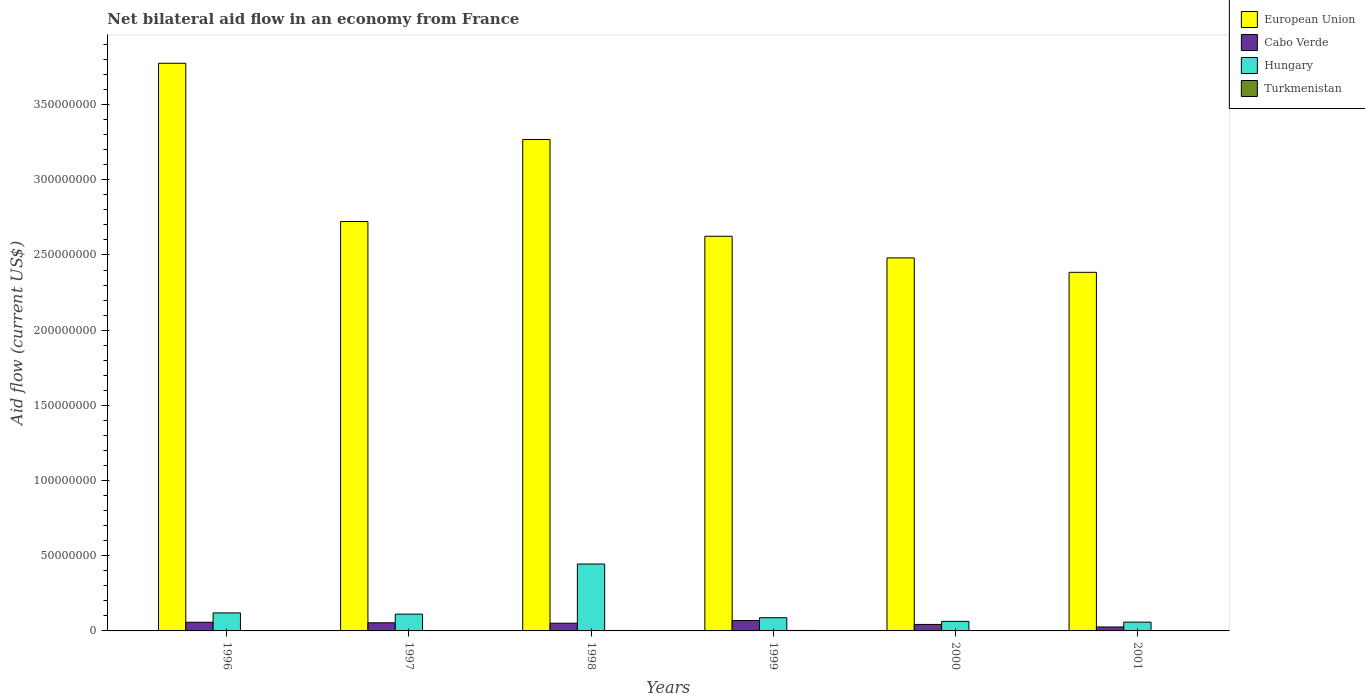How many groups of bars are there?
Make the answer very short. 6. Are the number of bars per tick equal to the number of legend labels?
Ensure brevity in your answer.  Yes. Are the number of bars on each tick of the X-axis equal?
Your response must be concise. Yes. How many bars are there on the 6th tick from the left?
Your answer should be compact. 4. How many bars are there on the 2nd tick from the right?
Provide a short and direct response. 4. In how many cases, is the number of bars for a given year not equal to the number of legend labels?
Your answer should be very brief. 0. What is the net bilateral aid flow in Cabo Verde in 1999?
Provide a succinct answer. 6.93e+06. Across all years, what is the maximum net bilateral aid flow in Hungary?
Your response must be concise. 4.45e+07. Across all years, what is the minimum net bilateral aid flow in European Union?
Provide a succinct answer. 2.38e+08. In which year was the net bilateral aid flow in Turkmenistan maximum?
Offer a terse response. 1999. In which year was the net bilateral aid flow in European Union minimum?
Your response must be concise. 2001. What is the total net bilateral aid flow in Turkmenistan in the graph?
Your answer should be very brief. 1.59e+06. What is the difference between the net bilateral aid flow in Hungary in 1998 and that in 2001?
Offer a terse response. 3.86e+07. What is the difference between the net bilateral aid flow in European Union in 2001 and the net bilateral aid flow in Cabo Verde in 1996?
Your response must be concise. 2.33e+08. What is the average net bilateral aid flow in European Union per year?
Offer a very short reply. 2.88e+08. In the year 2001, what is the difference between the net bilateral aid flow in Cabo Verde and net bilateral aid flow in Hungary?
Your answer should be compact. -3.22e+06. In how many years, is the net bilateral aid flow in Hungary greater than 10000000 US$?
Offer a terse response. 3. What is the ratio of the net bilateral aid flow in Turkmenistan in 1996 to that in 1998?
Provide a short and direct response. 0.97. Is the net bilateral aid flow in European Union in 1997 less than that in 1998?
Ensure brevity in your answer.  Yes. What is the difference between the highest and the second highest net bilateral aid flow in Cabo Verde?
Offer a terse response. 1.16e+06. What is the difference between the highest and the lowest net bilateral aid flow in Turkmenistan?
Provide a short and direct response. 1.40e+05. What does the 3rd bar from the right in 2001 represents?
Offer a very short reply. Cabo Verde. How many years are there in the graph?
Your answer should be very brief. 6. What is the difference between two consecutive major ticks on the Y-axis?
Ensure brevity in your answer.  5.00e+07. Are the values on the major ticks of Y-axis written in scientific E-notation?
Your answer should be compact. No. Does the graph contain any zero values?
Your answer should be compact. No. Where does the legend appear in the graph?
Keep it short and to the point. Top right. How are the legend labels stacked?
Give a very brief answer. Vertical. What is the title of the graph?
Give a very brief answer. Net bilateral aid flow in an economy from France. What is the label or title of the X-axis?
Offer a terse response. Years. What is the Aid flow (current US$) of European Union in 1996?
Make the answer very short. 3.78e+08. What is the Aid flow (current US$) of Cabo Verde in 1996?
Give a very brief answer. 5.77e+06. What is the Aid flow (current US$) of Hungary in 1996?
Ensure brevity in your answer.  1.20e+07. What is the Aid flow (current US$) of Turkmenistan in 1996?
Ensure brevity in your answer.  2.90e+05. What is the Aid flow (current US$) of European Union in 1997?
Your response must be concise. 2.72e+08. What is the Aid flow (current US$) of Cabo Verde in 1997?
Provide a short and direct response. 5.40e+06. What is the Aid flow (current US$) in Hungary in 1997?
Your answer should be very brief. 1.12e+07. What is the Aid flow (current US$) of Turkmenistan in 1997?
Keep it short and to the point. 2.20e+05. What is the Aid flow (current US$) in European Union in 1998?
Your answer should be compact. 3.27e+08. What is the Aid flow (current US$) of Cabo Verde in 1998?
Your answer should be compact. 5.13e+06. What is the Aid flow (current US$) in Hungary in 1998?
Provide a short and direct response. 4.45e+07. What is the Aid flow (current US$) in Turkmenistan in 1998?
Your response must be concise. 3.00e+05. What is the Aid flow (current US$) of European Union in 1999?
Keep it short and to the point. 2.62e+08. What is the Aid flow (current US$) in Cabo Verde in 1999?
Your answer should be very brief. 6.93e+06. What is the Aid flow (current US$) in Hungary in 1999?
Your answer should be compact. 8.77e+06. What is the Aid flow (current US$) in Turkmenistan in 1999?
Your answer should be compact. 3.20e+05. What is the Aid flow (current US$) in European Union in 2000?
Offer a terse response. 2.48e+08. What is the Aid flow (current US$) in Cabo Verde in 2000?
Provide a short and direct response. 4.32e+06. What is the Aid flow (current US$) in Hungary in 2000?
Keep it short and to the point. 6.36e+06. What is the Aid flow (current US$) in Turkmenistan in 2000?
Ensure brevity in your answer.  1.80e+05. What is the Aid flow (current US$) in European Union in 2001?
Make the answer very short. 2.38e+08. What is the Aid flow (current US$) in Cabo Verde in 2001?
Provide a short and direct response. 2.62e+06. What is the Aid flow (current US$) in Hungary in 2001?
Keep it short and to the point. 5.84e+06. Across all years, what is the maximum Aid flow (current US$) in European Union?
Give a very brief answer. 3.78e+08. Across all years, what is the maximum Aid flow (current US$) of Cabo Verde?
Your answer should be compact. 6.93e+06. Across all years, what is the maximum Aid flow (current US$) in Hungary?
Give a very brief answer. 4.45e+07. Across all years, what is the maximum Aid flow (current US$) in Turkmenistan?
Your answer should be compact. 3.20e+05. Across all years, what is the minimum Aid flow (current US$) of European Union?
Offer a terse response. 2.38e+08. Across all years, what is the minimum Aid flow (current US$) of Cabo Verde?
Keep it short and to the point. 2.62e+06. Across all years, what is the minimum Aid flow (current US$) in Hungary?
Offer a very short reply. 5.84e+06. What is the total Aid flow (current US$) of European Union in the graph?
Ensure brevity in your answer.  1.73e+09. What is the total Aid flow (current US$) of Cabo Verde in the graph?
Ensure brevity in your answer.  3.02e+07. What is the total Aid flow (current US$) of Hungary in the graph?
Your response must be concise. 8.86e+07. What is the total Aid flow (current US$) of Turkmenistan in the graph?
Provide a succinct answer. 1.59e+06. What is the difference between the Aid flow (current US$) of European Union in 1996 and that in 1997?
Keep it short and to the point. 1.05e+08. What is the difference between the Aid flow (current US$) in European Union in 1996 and that in 1998?
Offer a very short reply. 5.07e+07. What is the difference between the Aid flow (current US$) in Cabo Verde in 1996 and that in 1998?
Ensure brevity in your answer.  6.40e+05. What is the difference between the Aid flow (current US$) in Hungary in 1996 and that in 1998?
Offer a very short reply. -3.25e+07. What is the difference between the Aid flow (current US$) of Turkmenistan in 1996 and that in 1998?
Your answer should be compact. -10000. What is the difference between the Aid flow (current US$) of European Union in 1996 and that in 1999?
Provide a succinct answer. 1.15e+08. What is the difference between the Aid flow (current US$) of Cabo Verde in 1996 and that in 1999?
Keep it short and to the point. -1.16e+06. What is the difference between the Aid flow (current US$) of Hungary in 1996 and that in 1999?
Offer a very short reply. 3.21e+06. What is the difference between the Aid flow (current US$) of European Union in 1996 and that in 2000?
Your answer should be compact. 1.29e+08. What is the difference between the Aid flow (current US$) of Cabo Verde in 1996 and that in 2000?
Your answer should be very brief. 1.45e+06. What is the difference between the Aid flow (current US$) in Hungary in 1996 and that in 2000?
Offer a terse response. 5.62e+06. What is the difference between the Aid flow (current US$) in European Union in 1996 and that in 2001?
Offer a terse response. 1.39e+08. What is the difference between the Aid flow (current US$) in Cabo Verde in 1996 and that in 2001?
Offer a terse response. 3.15e+06. What is the difference between the Aid flow (current US$) in Hungary in 1996 and that in 2001?
Your answer should be very brief. 6.14e+06. What is the difference between the Aid flow (current US$) in European Union in 1997 and that in 1998?
Offer a very short reply. -5.46e+07. What is the difference between the Aid flow (current US$) of Hungary in 1997 and that in 1998?
Provide a short and direct response. -3.33e+07. What is the difference between the Aid flow (current US$) of Turkmenistan in 1997 and that in 1998?
Your answer should be compact. -8.00e+04. What is the difference between the Aid flow (current US$) in European Union in 1997 and that in 1999?
Provide a succinct answer. 9.80e+06. What is the difference between the Aid flow (current US$) of Cabo Verde in 1997 and that in 1999?
Give a very brief answer. -1.53e+06. What is the difference between the Aid flow (current US$) of Hungary in 1997 and that in 1999?
Your answer should be very brief. 2.41e+06. What is the difference between the Aid flow (current US$) of European Union in 1997 and that in 2000?
Make the answer very short. 2.42e+07. What is the difference between the Aid flow (current US$) of Cabo Verde in 1997 and that in 2000?
Offer a terse response. 1.08e+06. What is the difference between the Aid flow (current US$) of Hungary in 1997 and that in 2000?
Your answer should be very brief. 4.82e+06. What is the difference between the Aid flow (current US$) in European Union in 1997 and that in 2001?
Make the answer very short. 3.38e+07. What is the difference between the Aid flow (current US$) of Cabo Verde in 1997 and that in 2001?
Offer a very short reply. 2.78e+06. What is the difference between the Aid flow (current US$) in Hungary in 1997 and that in 2001?
Give a very brief answer. 5.34e+06. What is the difference between the Aid flow (current US$) of European Union in 1998 and that in 1999?
Offer a terse response. 6.44e+07. What is the difference between the Aid flow (current US$) in Cabo Verde in 1998 and that in 1999?
Ensure brevity in your answer.  -1.80e+06. What is the difference between the Aid flow (current US$) in Hungary in 1998 and that in 1999?
Keep it short and to the point. 3.57e+07. What is the difference between the Aid flow (current US$) in European Union in 1998 and that in 2000?
Your response must be concise. 7.88e+07. What is the difference between the Aid flow (current US$) in Cabo Verde in 1998 and that in 2000?
Offer a terse response. 8.10e+05. What is the difference between the Aid flow (current US$) in Hungary in 1998 and that in 2000?
Keep it short and to the point. 3.81e+07. What is the difference between the Aid flow (current US$) in European Union in 1998 and that in 2001?
Offer a terse response. 8.84e+07. What is the difference between the Aid flow (current US$) in Cabo Verde in 1998 and that in 2001?
Make the answer very short. 2.51e+06. What is the difference between the Aid flow (current US$) in Hungary in 1998 and that in 2001?
Make the answer very short. 3.86e+07. What is the difference between the Aid flow (current US$) of European Union in 1999 and that in 2000?
Keep it short and to the point. 1.44e+07. What is the difference between the Aid flow (current US$) in Cabo Verde in 1999 and that in 2000?
Provide a succinct answer. 2.61e+06. What is the difference between the Aid flow (current US$) in Hungary in 1999 and that in 2000?
Make the answer very short. 2.41e+06. What is the difference between the Aid flow (current US$) of Turkmenistan in 1999 and that in 2000?
Your answer should be very brief. 1.40e+05. What is the difference between the Aid flow (current US$) in European Union in 1999 and that in 2001?
Make the answer very short. 2.40e+07. What is the difference between the Aid flow (current US$) of Cabo Verde in 1999 and that in 2001?
Provide a short and direct response. 4.31e+06. What is the difference between the Aid flow (current US$) in Hungary in 1999 and that in 2001?
Give a very brief answer. 2.93e+06. What is the difference between the Aid flow (current US$) of Turkmenistan in 1999 and that in 2001?
Your answer should be compact. 4.00e+04. What is the difference between the Aid flow (current US$) in European Union in 2000 and that in 2001?
Make the answer very short. 9.59e+06. What is the difference between the Aid flow (current US$) in Cabo Verde in 2000 and that in 2001?
Keep it short and to the point. 1.70e+06. What is the difference between the Aid flow (current US$) of Hungary in 2000 and that in 2001?
Provide a succinct answer. 5.20e+05. What is the difference between the Aid flow (current US$) of European Union in 1996 and the Aid flow (current US$) of Cabo Verde in 1997?
Your response must be concise. 3.72e+08. What is the difference between the Aid flow (current US$) of European Union in 1996 and the Aid flow (current US$) of Hungary in 1997?
Your response must be concise. 3.66e+08. What is the difference between the Aid flow (current US$) in European Union in 1996 and the Aid flow (current US$) in Turkmenistan in 1997?
Your answer should be compact. 3.77e+08. What is the difference between the Aid flow (current US$) of Cabo Verde in 1996 and the Aid flow (current US$) of Hungary in 1997?
Your answer should be very brief. -5.41e+06. What is the difference between the Aid flow (current US$) in Cabo Verde in 1996 and the Aid flow (current US$) in Turkmenistan in 1997?
Ensure brevity in your answer.  5.55e+06. What is the difference between the Aid flow (current US$) of Hungary in 1996 and the Aid flow (current US$) of Turkmenistan in 1997?
Your answer should be very brief. 1.18e+07. What is the difference between the Aid flow (current US$) of European Union in 1996 and the Aid flow (current US$) of Cabo Verde in 1998?
Offer a very short reply. 3.72e+08. What is the difference between the Aid flow (current US$) of European Union in 1996 and the Aid flow (current US$) of Hungary in 1998?
Ensure brevity in your answer.  3.33e+08. What is the difference between the Aid flow (current US$) of European Union in 1996 and the Aid flow (current US$) of Turkmenistan in 1998?
Give a very brief answer. 3.77e+08. What is the difference between the Aid flow (current US$) in Cabo Verde in 1996 and the Aid flow (current US$) in Hungary in 1998?
Make the answer very short. -3.87e+07. What is the difference between the Aid flow (current US$) in Cabo Verde in 1996 and the Aid flow (current US$) in Turkmenistan in 1998?
Ensure brevity in your answer.  5.47e+06. What is the difference between the Aid flow (current US$) of Hungary in 1996 and the Aid flow (current US$) of Turkmenistan in 1998?
Provide a succinct answer. 1.17e+07. What is the difference between the Aid flow (current US$) of European Union in 1996 and the Aid flow (current US$) of Cabo Verde in 1999?
Give a very brief answer. 3.71e+08. What is the difference between the Aid flow (current US$) in European Union in 1996 and the Aid flow (current US$) in Hungary in 1999?
Ensure brevity in your answer.  3.69e+08. What is the difference between the Aid flow (current US$) in European Union in 1996 and the Aid flow (current US$) in Turkmenistan in 1999?
Offer a very short reply. 3.77e+08. What is the difference between the Aid flow (current US$) in Cabo Verde in 1996 and the Aid flow (current US$) in Hungary in 1999?
Provide a succinct answer. -3.00e+06. What is the difference between the Aid flow (current US$) of Cabo Verde in 1996 and the Aid flow (current US$) of Turkmenistan in 1999?
Provide a short and direct response. 5.45e+06. What is the difference between the Aid flow (current US$) in Hungary in 1996 and the Aid flow (current US$) in Turkmenistan in 1999?
Keep it short and to the point. 1.17e+07. What is the difference between the Aid flow (current US$) in European Union in 1996 and the Aid flow (current US$) in Cabo Verde in 2000?
Make the answer very short. 3.73e+08. What is the difference between the Aid flow (current US$) of European Union in 1996 and the Aid flow (current US$) of Hungary in 2000?
Provide a succinct answer. 3.71e+08. What is the difference between the Aid flow (current US$) in European Union in 1996 and the Aid flow (current US$) in Turkmenistan in 2000?
Offer a very short reply. 3.77e+08. What is the difference between the Aid flow (current US$) of Cabo Verde in 1996 and the Aid flow (current US$) of Hungary in 2000?
Your answer should be very brief. -5.90e+05. What is the difference between the Aid flow (current US$) in Cabo Verde in 1996 and the Aid flow (current US$) in Turkmenistan in 2000?
Offer a terse response. 5.59e+06. What is the difference between the Aid flow (current US$) in Hungary in 1996 and the Aid flow (current US$) in Turkmenistan in 2000?
Provide a short and direct response. 1.18e+07. What is the difference between the Aid flow (current US$) in European Union in 1996 and the Aid flow (current US$) in Cabo Verde in 2001?
Make the answer very short. 3.75e+08. What is the difference between the Aid flow (current US$) in European Union in 1996 and the Aid flow (current US$) in Hungary in 2001?
Keep it short and to the point. 3.72e+08. What is the difference between the Aid flow (current US$) of European Union in 1996 and the Aid flow (current US$) of Turkmenistan in 2001?
Offer a very short reply. 3.77e+08. What is the difference between the Aid flow (current US$) of Cabo Verde in 1996 and the Aid flow (current US$) of Turkmenistan in 2001?
Give a very brief answer. 5.49e+06. What is the difference between the Aid flow (current US$) in Hungary in 1996 and the Aid flow (current US$) in Turkmenistan in 2001?
Offer a very short reply. 1.17e+07. What is the difference between the Aid flow (current US$) of European Union in 1997 and the Aid flow (current US$) of Cabo Verde in 1998?
Offer a very short reply. 2.67e+08. What is the difference between the Aid flow (current US$) of European Union in 1997 and the Aid flow (current US$) of Hungary in 1998?
Ensure brevity in your answer.  2.28e+08. What is the difference between the Aid flow (current US$) of European Union in 1997 and the Aid flow (current US$) of Turkmenistan in 1998?
Provide a succinct answer. 2.72e+08. What is the difference between the Aid flow (current US$) in Cabo Verde in 1997 and the Aid flow (current US$) in Hungary in 1998?
Provide a succinct answer. -3.91e+07. What is the difference between the Aid flow (current US$) in Cabo Verde in 1997 and the Aid flow (current US$) in Turkmenistan in 1998?
Your response must be concise. 5.10e+06. What is the difference between the Aid flow (current US$) in Hungary in 1997 and the Aid flow (current US$) in Turkmenistan in 1998?
Your answer should be compact. 1.09e+07. What is the difference between the Aid flow (current US$) in European Union in 1997 and the Aid flow (current US$) in Cabo Verde in 1999?
Provide a succinct answer. 2.65e+08. What is the difference between the Aid flow (current US$) in European Union in 1997 and the Aid flow (current US$) in Hungary in 1999?
Ensure brevity in your answer.  2.63e+08. What is the difference between the Aid flow (current US$) in European Union in 1997 and the Aid flow (current US$) in Turkmenistan in 1999?
Make the answer very short. 2.72e+08. What is the difference between the Aid flow (current US$) in Cabo Verde in 1997 and the Aid flow (current US$) in Hungary in 1999?
Your answer should be compact. -3.37e+06. What is the difference between the Aid flow (current US$) in Cabo Verde in 1997 and the Aid flow (current US$) in Turkmenistan in 1999?
Your answer should be compact. 5.08e+06. What is the difference between the Aid flow (current US$) of Hungary in 1997 and the Aid flow (current US$) of Turkmenistan in 1999?
Offer a very short reply. 1.09e+07. What is the difference between the Aid flow (current US$) of European Union in 1997 and the Aid flow (current US$) of Cabo Verde in 2000?
Provide a succinct answer. 2.68e+08. What is the difference between the Aid flow (current US$) in European Union in 1997 and the Aid flow (current US$) in Hungary in 2000?
Offer a very short reply. 2.66e+08. What is the difference between the Aid flow (current US$) in European Union in 1997 and the Aid flow (current US$) in Turkmenistan in 2000?
Your response must be concise. 2.72e+08. What is the difference between the Aid flow (current US$) of Cabo Verde in 1997 and the Aid flow (current US$) of Hungary in 2000?
Your answer should be compact. -9.60e+05. What is the difference between the Aid flow (current US$) in Cabo Verde in 1997 and the Aid flow (current US$) in Turkmenistan in 2000?
Keep it short and to the point. 5.22e+06. What is the difference between the Aid flow (current US$) of Hungary in 1997 and the Aid flow (current US$) of Turkmenistan in 2000?
Ensure brevity in your answer.  1.10e+07. What is the difference between the Aid flow (current US$) of European Union in 1997 and the Aid flow (current US$) of Cabo Verde in 2001?
Your answer should be compact. 2.70e+08. What is the difference between the Aid flow (current US$) of European Union in 1997 and the Aid flow (current US$) of Hungary in 2001?
Your answer should be very brief. 2.66e+08. What is the difference between the Aid flow (current US$) of European Union in 1997 and the Aid flow (current US$) of Turkmenistan in 2001?
Provide a short and direct response. 2.72e+08. What is the difference between the Aid flow (current US$) of Cabo Verde in 1997 and the Aid flow (current US$) of Hungary in 2001?
Your response must be concise. -4.40e+05. What is the difference between the Aid flow (current US$) of Cabo Verde in 1997 and the Aid flow (current US$) of Turkmenistan in 2001?
Make the answer very short. 5.12e+06. What is the difference between the Aid flow (current US$) of Hungary in 1997 and the Aid flow (current US$) of Turkmenistan in 2001?
Keep it short and to the point. 1.09e+07. What is the difference between the Aid flow (current US$) in European Union in 1998 and the Aid flow (current US$) in Cabo Verde in 1999?
Offer a terse response. 3.20e+08. What is the difference between the Aid flow (current US$) in European Union in 1998 and the Aid flow (current US$) in Hungary in 1999?
Give a very brief answer. 3.18e+08. What is the difference between the Aid flow (current US$) in European Union in 1998 and the Aid flow (current US$) in Turkmenistan in 1999?
Provide a short and direct response. 3.27e+08. What is the difference between the Aid flow (current US$) of Cabo Verde in 1998 and the Aid flow (current US$) of Hungary in 1999?
Your answer should be very brief. -3.64e+06. What is the difference between the Aid flow (current US$) of Cabo Verde in 1998 and the Aid flow (current US$) of Turkmenistan in 1999?
Your answer should be very brief. 4.81e+06. What is the difference between the Aid flow (current US$) of Hungary in 1998 and the Aid flow (current US$) of Turkmenistan in 1999?
Your answer should be very brief. 4.42e+07. What is the difference between the Aid flow (current US$) in European Union in 1998 and the Aid flow (current US$) in Cabo Verde in 2000?
Provide a succinct answer. 3.23e+08. What is the difference between the Aid flow (current US$) in European Union in 1998 and the Aid flow (current US$) in Hungary in 2000?
Your answer should be very brief. 3.20e+08. What is the difference between the Aid flow (current US$) of European Union in 1998 and the Aid flow (current US$) of Turkmenistan in 2000?
Make the answer very short. 3.27e+08. What is the difference between the Aid flow (current US$) in Cabo Verde in 1998 and the Aid flow (current US$) in Hungary in 2000?
Offer a terse response. -1.23e+06. What is the difference between the Aid flow (current US$) of Cabo Verde in 1998 and the Aid flow (current US$) of Turkmenistan in 2000?
Give a very brief answer. 4.95e+06. What is the difference between the Aid flow (current US$) of Hungary in 1998 and the Aid flow (current US$) of Turkmenistan in 2000?
Your answer should be compact. 4.43e+07. What is the difference between the Aid flow (current US$) in European Union in 1998 and the Aid flow (current US$) in Cabo Verde in 2001?
Your response must be concise. 3.24e+08. What is the difference between the Aid flow (current US$) in European Union in 1998 and the Aid flow (current US$) in Hungary in 2001?
Provide a short and direct response. 3.21e+08. What is the difference between the Aid flow (current US$) in European Union in 1998 and the Aid flow (current US$) in Turkmenistan in 2001?
Provide a short and direct response. 3.27e+08. What is the difference between the Aid flow (current US$) of Cabo Verde in 1998 and the Aid flow (current US$) of Hungary in 2001?
Make the answer very short. -7.10e+05. What is the difference between the Aid flow (current US$) in Cabo Verde in 1998 and the Aid flow (current US$) in Turkmenistan in 2001?
Keep it short and to the point. 4.85e+06. What is the difference between the Aid flow (current US$) in Hungary in 1998 and the Aid flow (current US$) in Turkmenistan in 2001?
Make the answer very short. 4.42e+07. What is the difference between the Aid flow (current US$) of European Union in 1999 and the Aid flow (current US$) of Cabo Verde in 2000?
Provide a succinct answer. 2.58e+08. What is the difference between the Aid flow (current US$) of European Union in 1999 and the Aid flow (current US$) of Hungary in 2000?
Give a very brief answer. 2.56e+08. What is the difference between the Aid flow (current US$) in European Union in 1999 and the Aid flow (current US$) in Turkmenistan in 2000?
Give a very brief answer. 2.62e+08. What is the difference between the Aid flow (current US$) of Cabo Verde in 1999 and the Aid flow (current US$) of Hungary in 2000?
Offer a very short reply. 5.70e+05. What is the difference between the Aid flow (current US$) of Cabo Verde in 1999 and the Aid flow (current US$) of Turkmenistan in 2000?
Your answer should be compact. 6.75e+06. What is the difference between the Aid flow (current US$) in Hungary in 1999 and the Aid flow (current US$) in Turkmenistan in 2000?
Ensure brevity in your answer.  8.59e+06. What is the difference between the Aid flow (current US$) in European Union in 1999 and the Aid flow (current US$) in Cabo Verde in 2001?
Offer a very short reply. 2.60e+08. What is the difference between the Aid flow (current US$) of European Union in 1999 and the Aid flow (current US$) of Hungary in 2001?
Offer a terse response. 2.57e+08. What is the difference between the Aid flow (current US$) in European Union in 1999 and the Aid flow (current US$) in Turkmenistan in 2001?
Your response must be concise. 2.62e+08. What is the difference between the Aid flow (current US$) in Cabo Verde in 1999 and the Aid flow (current US$) in Hungary in 2001?
Keep it short and to the point. 1.09e+06. What is the difference between the Aid flow (current US$) in Cabo Verde in 1999 and the Aid flow (current US$) in Turkmenistan in 2001?
Your answer should be very brief. 6.65e+06. What is the difference between the Aid flow (current US$) in Hungary in 1999 and the Aid flow (current US$) in Turkmenistan in 2001?
Provide a short and direct response. 8.49e+06. What is the difference between the Aid flow (current US$) in European Union in 2000 and the Aid flow (current US$) in Cabo Verde in 2001?
Provide a succinct answer. 2.45e+08. What is the difference between the Aid flow (current US$) of European Union in 2000 and the Aid flow (current US$) of Hungary in 2001?
Your answer should be very brief. 2.42e+08. What is the difference between the Aid flow (current US$) of European Union in 2000 and the Aid flow (current US$) of Turkmenistan in 2001?
Your answer should be very brief. 2.48e+08. What is the difference between the Aid flow (current US$) of Cabo Verde in 2000 and the Aid flow (current US$) of Hungary in 2001?
Your answer should be very brief. -1.52e+06. What is the difference between the Aid flow (current US$) in Cabo Verde in 2000 and the Aid flow (current US$) in Turkmenistan in 2001?
Make the answer very short. 4.04e+06. What is the difference between the Aid flow (current US$) in Hungary in 2000 and the Aid flow (current US$) in Turkmenistan in 2001?
Your answer should be compact. 6.08e+06. What is the average Aid flow (current US$) of European Union per year?
Your answer should be compact. 2.88e+08. What is the average Aid flow (current US$) in Cabo Verde per year?
Give a very brief answer. 5.03e+06. What is the average Aid flow (current US$) of Hungary per year?
Ensure brevity in your answer.  1.48e+07. What is the average Aid flow (current US$) of Turkmenistan per year?
Your answer should be very brief. 2.65e+05. In the year 1996, what is the difference between the Aid flow (current US$) of European Union and Aid flow (current US$) of Cabo Verde?
Offer a terse response. 3.72e+08. In the year 1996, what is the difference between the Aid flow (current US$) in European Union and Aid flow (current US$) in Hungary?
Your response must be concise. 3.66e+08. In the year 1996, what is the difference between the Aid flow (current US$) in European Union and Aid flow (current US$) in Turkmenistan?
Keep it short and to the point. 3.77e+08. In the year 1996, what is the difference between the Aid flow (current US$) of Cabo Verde and Aid flow (current US$) of Hungary?
Give a very brief answer. -6.21e+06. In the year 1996, what is the difference between the Aid flow (current US$) of Cabo Verde and Aid flow (current US$) of Turkmenistan?
Ensure brevity in your answer.  5.48e+06. In the year 1996, what is the difference between the Aid flow (current US$) of Hungary and Aid flow (current US$) of Turkmenistan?
Offer a terse response. 1.17e+07. In the year 1997, what is the difference between the Aid flow (current US$) in European Union and Aid flow (current US$) in Cabo Verde?
Your answer should be compact. 2.67e+08. In the year 1997, what is the difference between the Aid flow (current US$) in European Union and Aid flow (current US$) in Hungary?
Your response must be concise. 2.61e+08. In the year 1997, what is the difference between the Aid flow (current US$) of European Union and Aid flow (current US$) of Turkmenistan?
Your answer should be very brief. 2.72e+08. In the year 1997, what is the difference between the Aid flow (current US$) of Cabo Verde and Aid flow (current US$) of Hungary?
Ensure brevity in your answer.  -5.78e+06. In the year 1997, what is the difference between the Aid flow (current US$) of Cabo Verde and Aid flow (current US$) of Turkmenistan?
Your answer should be compact. 5.18e+06. In the year 1997, what is the difference between the Aid flow (current US$) in Hungary and Aid flow (current US$) in Turkmenistan?
Offer a very short reply. 1.10e+07. In the year 1998, what is the difference between the Aid flow (current US$) in European Union and Aid flow (current US$) in Cabo Verde?
Offer a very short reply. 3.22e+08. In the year 1998, what is the difference between the Aid flow (current US$) in European Union and Aid flow (current US$) in Hungary?
Ensure brevity in your answer.  2.82e+08. In the year 1998, what is the difference between the Aid flow (current US$) of European Union and Aid flow (current US$) of Turkmenistan?
Ensure brevity in your answer.  3.27e+08. In the year 1998, what is the difference between the Aid flow (current US$) of Cabo Verde and Aid flow (current US$) of Hungary?
Ensure brevity in your answer.  -3.94e+07. In the year 1998, what is the difference between the Aid flow (current US$) in Cabo Verde and Aid flow (current US$) in Turkmenistan?
Your response must be concise. 4.83e+06. In the year 1998, what is the difference between the Aid flow (current US$) of Hungary and Aid flow (current US$) of Turkmenistan?
Provide a succinct answer. 4.42e+07. In the year 1999, what is the difference between the Aid flow (current US$) of European Union and Aid flow (current US$) of Cabo Verde?
Keep it short and to the point. 2.56e+08. In the year 1999, what is the difference between the Aid flow (current US$) in European Union and Aid flow (current US$) in Hungary?
Ensure brevity in your answer.  2.54e+08. In the year 1999, what is the difference between the Aid flow (current US$) of European Union and Aid flow (current US$) of Turkmenistan?
Your answer should be very brief. 2.62e+08. In the year 1999, what is the difference between the Aid flow (current US$) of Cabo Verde and Aid flow (current US$) of Hungary?
Your answer should be very brief. -1.84e+06. In the year 1999, what is the difference between the Aid flow (current US$) of Cabo Verde and Aid flow (current US$) of Turkmenistan?
Make the answer very short. 6.61e+06. In the year 1999, what is the difference between the Aid flow (current US$) in Hungary and Aid flow (current US$) in Turkmenistan?
Provide a short and direct response. 8.45e+06. In the year 2000, what is the difference between the Aid flow (current US$) of European Union and Aid flow (current US$) of Cabo Verde?
Offer a very short reply. 2.44e+08. In the year 2000, what is the difference between the Aid flow (current US$) in European Union and Aid flow (current US$) in Hungary?
Offer a very short reply. 2.42e+08. In the year 2000, what is the difference between the Aid flow (current US$) of European Union and Aid flow (current US$) of Turkmenistan?
Your answer should be compact. 2.48e+08. In the year 2000, what is the difference between the Aid flow (current US$) of Cabo Verde and Aid flow (current US$) of Hungary?
Offer a very short reply. -2.04e+06. In the year 2000, what is the difference between the Aid flow (current US$) in Cabo Verde and Aid flow (current US$) in Turkmenistan?
Offer a terse response. 4.14e+06. In the year 2000, what is the difference between the Aid flow (current US$) in Hungary and Aid flow (current US$) in Turkmenistan?
Your answer should be compact. 6.18e+06. In the year 2001, what is the difference between the Aid flow (current US$) of European Union and Aid flow (current US$) of Cabo Verde?
Offer a very short reply. 2.36e+08. In the year 2001, what is the difference between the Aid flow (current US$) in European Union and Aid flow (current US$) in Hungary?
Your answer should be very brief. 2.33e+08. In the year 2001, what is the difference between the Aid flow (current US$) of European Union and Aid flow (current US$) of Turkmenistan?
Ensure brevity in your answer.  2.38e+08. In the year 2001, what is the difference between the Aid flow (current US$) of Cabo Verde and Aid flow (current US$) of Hungary?
Keep it short and to the point. -3.22e+06. In the year 2001, what is the difference between the Aid flow (current US$) of Cabo Verde and Aid flow (current US$) of Turkmenistan?
Keep it short and to the point. 2.34e+06. In the year 2001, what is the difference between the Aid flow (current US$) in Hungary and Aid flow (current US$) in Turkmenistan?
Provide a short and direct response. 5.56e+06. What is the ratio of the Aid flow (current US$) in European Union in 1996 to that in 1997?
Your answer should be very brief. 1.39. What is the ratio of the Aid flow (current US$) in Cabo Verde in 1996 to that in 1997?
Your answer should be compact. 1.07. What is the ratio of the Aid flow (current US$) in Hungary in 1996 to that in 1997?
Keep it short and to the point. 1.07. What is the ratio of the Aid flow (current US$) of Turkmenistan in 1996 to that in 1997?
Provide a short and direct response. 1.32. What is the ratio of the Aid flow (current US$) in European Union in 1996 to that in 1998?
Your answer should be compact. 1.16. What is the ratio of the Aid flow (current US$) of Cabo Verde in 1996 to that in 1998?
Keep it short and to the point. 1.12. What is the ratio of the Aid flow (current US$) of Hungary in 1996 to that in 1998?
Offer a terse response. 0.27. What is the ratio of the Aid flow (current US$) of Turkmenistan in 1996 to that in 1998?
Keep it short and to the point. 0.97. What is the ratio of the Aid flow (current US$) of European Union in 1996 to that in 1999?
Offer a terse response. 1.44. What is the ratio of the Aid flow (current US$) in Cabo Verde in 1996 to that in 1999?
Your answer should be compact. 0.83. What is the ratio of the Aid flow (current US$) in Hungary in 1996 to that in 1999?
Provide a short and direct response. 1.37. What is the ratio of the Aid flow (current US$) in Turkmenistan in 1996 to that in 1999?
Make the answer very short. 0.91. What is the ratio of the Aid flow (current US$) in European Union in 1996 to that in 2000?
Keep it short and to the point. 1.52. What is the ratio of the Aid flow (current US$) in Cabo Verde in 1996 to that in 2000?
Make the answer very short. 1.34. What is the ratio of the Aid flow (current US$) of Hungary in 1996 to that in 2000?
Keep it short and to the point. 1.88. What is the ratio of the Aid flow (current US$) of Turkmenistan in 1996 to that in 2000?
Your answer should be very brief. 1.61. What is the ratio of the Aid flow (current US$) of European Union in 1996 to that in 2001?
Offer a very short reply. 1.58. What is the ratio of the Aid flow (current US$) in Cabo Verde in 1996 to that in 2001?
Offer a very short reply. 2.2. What is the ratio of the Aid flow (current US$) in Hungary in 1996 to that in 2001?
Ensure brevity in your answer.  2.05. What is the ratio of the Aid flow (current US$) in Turkmenistan in 1996 to that in 2001?
Provide a short and direct response. 1.04. What is the ratio of the Aid flow (current US$) of European Union in 1997 to that in 1998?
Provide a succinct answer. 0.83. What is the ratio of the Aid flow (current US$) in Cabo Verde in 1997 to that in 1998?
Make the answer very short. 1.05. What is the ratio of the Aid flow (current US$) of Hungary in 1997 to that in 1998?
Keep it short and to the point. 0.25. What is the ratio of the Aid flow (current US$) in Turkmenistan in 1997 to that in 1998?
Provide a short and direct response. 0.73. What is the ratio of the Aid flow (current US$) in European Union in 1997 to that in 1999?
Make the answer very short. 1.04. What is the ratio of the Aid flow (current US$) of Cabo Verde in 1997 to that in 1999?
Provide a succinct answer. 0.78. What is the ratio of the Aid flow (current US$) of Hungary in 1997 to that in 1999?
Your answer should be very brief. 1.27. What is the ratio of the Aid flow (current US$) in Turkmenistan in 1997 to that in 1999?
Your response must be concise. 0.69. What is the ratio of the Aid flow (current US$) of European Union in 1997 to that in 2000?
Offer a very short reply. 1.1. What is the ratio of the Aid flow (current US$) of Hungary in 1997 to that in 2000?
Offer a very short reply. 1.76. What is the ratio of the Aid flow (current US$) in Turkmenistan in 1997 to that in 2000?
Offer a terse response. 1.22. What is the ratio of the Aid flow (current US$) of European Union in 1997 to that in 2001?
Offer a terse response. 1.14. What is the ratio of the Aid flow (current US$) in Cabo Verde in 1997 to that in 2001?
Offer a terse response. 2.06. What is the ratio of the Aid flow (current US$) in Hungary in 1997 to that in 2001?
Your answer should be compact. 1.91. What is the ratio of the Aid flow (current US$) of Turkmenistan in 1997 to that in 2001?
Your response must be concise. 0.79. What is the ratio of the Aid flow (current US$) of European Union in 1998 to that in 1999?
Your response must be concise. 1.25. What is the ratio of the Aid flow (current US$) of Cabo Verde in 1998 to that in 1999?
Your response must be concise. 0.74. What is the ratio of the Aid flow (current US$) of Hungary in 1998 to that in 1999?
Your response must be concise. 5.07. What is the ratio of the Aid flow (current US$) in European Union in 1998 to that in 2000?
Provide a succinct answer. 1.32. What is the ratio of the Aid flow (current US$) of Cabo Verde in 1998 to that in 2000?
Offer a very short reply. 1.19. What is the ratio of the Aid flow (current US$) of Hungary in 1998 to that in 2000?
Your answer should be compact. 7. What is the ratio of the Aid flow (current US$) of European Union in 1998 to that in 2001?
Offer a very short reply. 1.37. What is the ratio of the Aid flow (current US$) of Cabo Verde in 1998 to that in 2001?
Provide a succinct answer. 1.96. What is the ratio of the Aid flow (current US$) of Hungary in 1998 to that in 2001?
Provide a short and direct response. 7.62. What is the ratio of the Aid flow (current US$) of Turkmenistan in 1998 to that in 2001?
Your answer should be compact. 1.07. What is the ratio of the Aid flow (current US$) of European Union in 1999 to that in 2000?
Offer a terse response. 1.06. What is the ratio of the Aid flow (current US$) of Cabo Verde in 1999 to that in 2000?
Provide a short and direct response. 1.6. What is the ratio of the Aid flow (current US$) in Hungary in 1999 to that in 2000?
Offer a terse response. 1.38. What is the ratio of the Aid flow (current US$) in Turkmenistan in 1999 to that in 2000?
Offer a terse response. 1.78. What is the ratio of the Aid flow (current US$) in European Union in 1999 to that in 2001?
Ensure brevity in your answer.  1.1. What is the ratio of the Aid flow (current US$) of Cabo Verde in 1999 to that in 2001?
Offer a very short reply. 2.65. What is the ratio of the Aid flow (current US$) of Hungary in 1999 to that in 2001?
Your answer should be compact. 1.5. What is the ratio of the Aid flow (current US$) of Turkmenistan in 1999 to that in 2001?
Provide a succinct answer. 1.14. What is the ratio of the Aid flow (current US$) in European Union in 2000 to that in 2001?
Provide a succinct answer. 1.04. What is the ratio of the Aid flow (current US$) in Cabo Verde in 2000 to that in 2001?
Offer a very short reply. 1.65. What is the ratio of the Aid flow (current US$) of Hungary in 2000 to that in 2001?
Provide a succinct answer. 1.09. What is the ratio of the Aid flow (current US$) in Turkmenistan in 2000 to that in 2001?
Your answer should be very brief. 0.64. What is the difference between the highest and the second highest Aid flow (current US$) in European Union?
Ensure brevity in your answer.  5.07e+07. What is the difference between the highest and the second highest Aid flow (current US$) in Cabo Verde?
Offer a very short reply. 1.16e+06. What is the difference between the highest and the second highest Aid flow (current US$) in Hungary?
Your answer should be very brief. 3.25e+07. What is the difference between the highest and the second highest Aid flow (current US$) in Turkmenistan?
Offer a terse response. 2.00e+04. What is the difference between the highest and the lowest Aid flow (current US$) of European Union?
Your response must be concise. 1.39e+08. What is the difference between the highest and the lowest Aid flow (current US$) in Cabo Verde?
Offer a very short reply. 4.31e+06. What is the difference between the highest and the lowest Aid flow (current US$) of Hungary?
Your answer should be compact. 3.86e+07. 